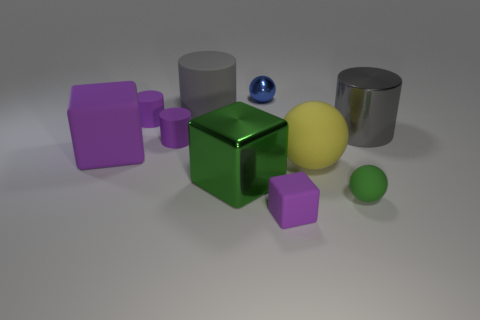Can you tell me more about the lighting in this scene? The lighting in the scene is soft and diffuse, suggesting an overcast sky or the presence of a large, perhaps window-sized light source out of view. There's a gentle shadow cast under each object, but no harsh, dark shadows that you would expect from a direct light source. The soft shadows help to subtly define the shapes of the objects. 